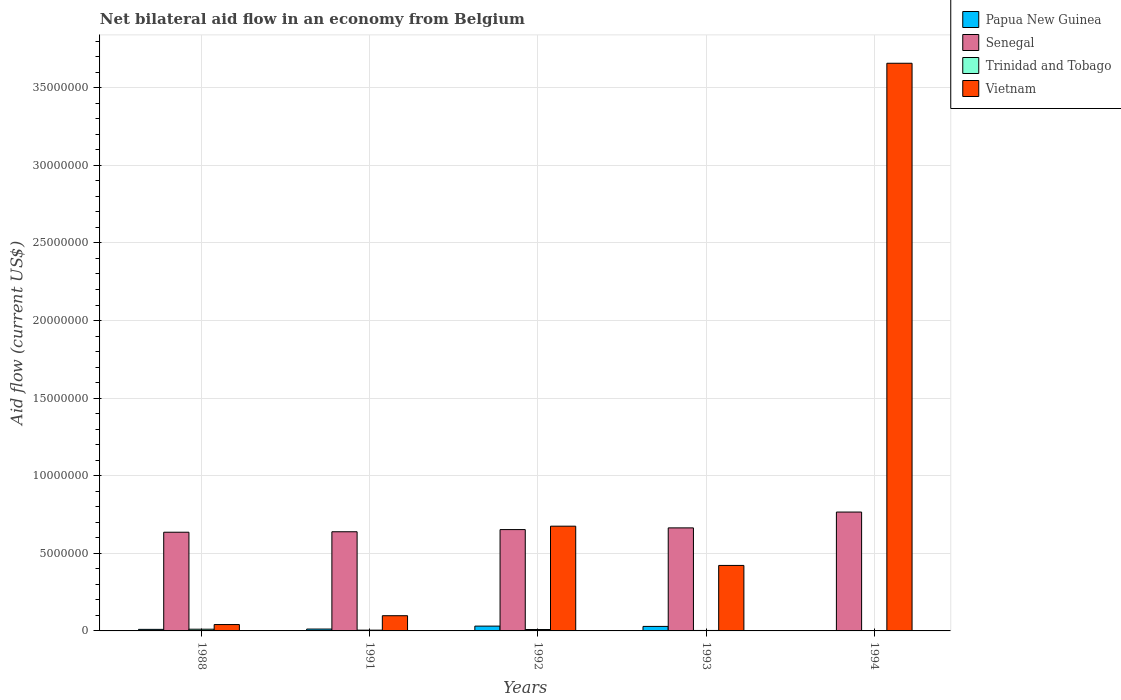Are the number of bars per tick equal to the number of legend labels?
Ensure brevity in your answer.  Yes. Are the number of bars on each tick of the X-axis equal?
Make the answer very short. Yes. How many bars are there on the 4th tick from the right?
Give a very brief answer. 4. In which year was the net bilateral aid flow in Vietnam minimum?
Ensure brevity in your answer.  1988. What is the total net bilateral aid flow in Vietnam in the graph?
Your response must be concise. 4.89e+07. What is the difference between the net bilateral aid flow in Senegal in 1992 and the net bilateral aid flow in Papua New Guinea in 1991?
Provide a short and direct response. 6.41e+06. What is the average net bilateral aid flow in Papua New Guinea per year?
Provide a succinct answer. 1.66e+05. In the year 1993, what is the difference between the net bilateral aid flow in Senegal and net bilateral aid flow in Papua New Guinea?
Offer a very short reply. 6.35e+06. In how many years, is the net bilateral aid flow in Trinidad and Tobago greater than 36000000 US$?
Your answer should be very brief. 0. What is the ratio of the net bilateral aid flow in Trinidad and Tobago in 1988 to that in 1993?
Your response must be concise. 3.67. What is the difference between the highest and the second highest net bilateral aid flow in Trinidad and Tobago?
Ensure brevity in your answer.  2.00e+04. Is the sum of the net bilateral aid flow in Trinidad and Tobago in 1988 and 1992 greater than the maximum net bilateral aid flow in Vietnam across all years?
Your response must be concise. No. Is it the case that in every year, the sum of the net bilateral aid flow in Vietnam and net bilateral aid flow in Senegal is greater than the sum of net bilateral aid flow in Papua New Guinea and net bilateral aid flow in Trinidad and Tobago?
Offer a terse response. Yes. What does the 1st bar from the left in 1993 represents?
Keep it short and to the point. Papua New Guinea. What does the 1st bar from the right in 1988 represents?
Give a very brief answer. Vietnam. How many years are there in the graph?
Make the answer very short. 5. What is the difference between two consecutive major ticks on the Y-axis?
Your answer should be very brief. 5.00e+06. Are the values on the major ticks of Y-axis written in scientific E-notation?
Provide a short and direct response. No. How are the legend labels stacked?
Your answer should be compact. Vertical. What is the title of the graph?
Offer a terse response. Net bilateral aid flow in an economy from Belgium. What is the label or title of the X-axis?
Keep it short and to the point. Years. What is the Aid flow (current US$) of Senegal in 1988?
Your response must be concise. 6.36e+06. What is the Aid flow (current US$) of Vietnam in 1988?
Give a very brief answer. 4.10e+05. What is the Aid flow (current US$) in Papua New Guinea in 1991?
Keep it short and to the point. 1.20e+05. What is the Aid flow (current US$) in Senegal in 1991?
Give a very brief answer. 6.39e+06. What is the Aid flow (current US$) in Trinidad and Tobago in 1991?
Ensure brevity in your answer.  5.00e+04. What is the Aid flow (current US$) in Vietnam in 1991?
Your answer should be compact. 9.80e+05. What is the Aid flow (current US$) of Senegal in 1992?
Provide a short and direct response. 6.53e+06. What is the Aid flow (current US$) in Vietnam in 1992?
Your answer should be compact. 6.75e+06. What is the Aid flow (current US$) in Papua New Guinea in 1993?
Ensure brevity in your answer.  2.90e+05. What is the Aid flow (current US$) of Senegal in 1993?
Ensure brevity in your answer.  6.64e+06. What is the Aid flow (current US$) of Vietnam in 1993?
Keep it short and to the point. 4.22e+06. What is the Aid flow (current US$) of Papua New Guinea in 1994?
Keep it short and to the point. 10000. What is the Aid flow (current US$) in Senegal in 1994?
Your answer should be compact. 7.66e+06. What is the Aid flow (current US$) of Trinidad and Tobago in 1994?
Provide a short and direct response. 10000. What is the Aid flow (current US$) in Vietnam in 1994?
Keep it short and to the point. 3.66e+07. Across all years, what is the maximum Aid flow (current US$) in Senegal?
Ensure brevity in your answer.  7.66e+06. Across all years, what is the maximum Aid flow (current US$) of Vietnam?
Make the answer very short. 3.66e+07. Across all years, what is the minimum Aid flow (current US$) of Senegal?
Your answer should be very brief. 6.36e+06. What is the total Aid flow (current US$) of Papua New Guinea in the graph?
Your response must be concise. 8.30e+05. What is the total Aid flow (current US$) in Senegal in the graph?
Offer a terse response. 3.36e+07. What is the total Aid flow (current US$) of Trinidad and Tobago in the graph?
Your response must be concise. 2.90e+05. What is the total Aid flow (current US$) in Vietnam in the graph?
Provide a short and direct response. 4.89e+07. What is the difference between the Aid flow (current US$) in Trinidad and Tobago in 1988 and that in 1991?
Provide a short and direct response. 6.00e+04. What is the difference between the Aid flow (current US$) of Vietnam in 1988 and that in 1991?
Provide a short and direct response. -5.70e+05. What is the difference between the Aid flow (current US$) of Papua New Guinea in 1988 and that in 1992?
Ensure brevity in your answer.  -2.10e+05. What is the difference between the Aid flow (current US$) of Senegal in 1988 and that in 1992?
Provide a short and direct response. -1.70e+05. What is the difference between the Aid flow (current US$) of Vietnam in 1988 and that in 1992?
Keep it short and to the point. -6.34e+06. What is the difference between the Aid flow (current US$) of Senegal in 1988 and that in 1993?
Offer a terse response. -2.80e+05. What is the difference between the Aid flow (current US$) of Vietnam in 1988 and that in 1993?
Provide a short and direct response. -3.81e+06. What is the difference between the Aid flow (current US$) in Papua New Guinea in 1988 and that in 1994?
Offer a very short reply. 9.00e+04. What is the difference between the Aid flow (current US$) in Senegal in 1988 and that in 1994?
Make the answer very short. -1.30e+06. What is the difference between the Aid flow (current US$) of Trinidad and Tobago in 1988 and that in 1994?
Offer a very short reply. 1.00e+05. What is the difference between the Aid flow (current US$) of Vietnam in 1988 and that in 1994?
Give a very brief answer. -3.62e+07. What is the difference between the Aid flow (current US$) in Senegal in 1991 and that in 1992?
Give a very brief answer. -1.40e+05. What is the difference between the Aid flow (current US$) of Vietnam in 1991 and that in 1992?
Offer a very short reply. -5.77e+06. What is the difference between the Aid flow (current US$) in Senegal in 1991 and that in 1993?
Keep it short and to the point. -2.50e+05. What is the difference between the Aid flow (current US$) of Trinidad and Tobago in 1991 and that in 1993?
Keep it short and to the point. 2.00e+04. What is the difference between the Aid flow (current US$) of Vietnam in 1991 and that in 1993?
Give a very brief answer. -3.24e+06. What is the difference between the Aid flow (current US$) in Senegal in 1991 and that in 1994?
Your answer should be very brief. -1.27e+06. What is the difference between the Aid flow (current US$) in Vietnam in 1991 and that in 1994?
Offer a terse response. -3.56e+07. What is the difference between the Aid flow (current US$) in Papua New Guinea in 1992 and that in 1993?
Your answer should be very brief. 2.00e+04. What is the difference between the Aid flow (current US$) in Trinidad and Tobago in 1992 and that in 1993?
Provide a short and direct response. 6.00e+04. What is the difference between the Aid flow (current US$) in Vietnam in 1992 and that in 1993?
Offer a very short reply. 2.53e+06. What is the difference between the Aid flow (current US$) of Senegal in 1992 and that in 1994?
Provide a short and direct response. -1.13e+06. What is the difference between the Aid flow (current US$) of Trinidad and Tobago in 1992 and that in 1994?
Your response must be concise. 8.00e+04. What is the difference between the Aid flow (current US$) of Vietnam in 1992 and that in 1994?
Provide a succinct answer. -2.98e+07. What is the difference between the Aid flow (current US$) in Senegal in 1993 and that in 1994?
Ensure brevity in your answer.  -1.02e+06. What is the difference between the Aid flow (current US$) of Trinidad and Tobago in 1993 and that in 1994?
Your response must be concise. 2.00e+04. What is the difference between the Aid flow (current US$) of Vietnam in 1993 and that in 1994?
Your answer should be compact. -3.24e+07. What is the difference between the Aid flow (current US$) of Papua New Guinea in 1988 and the Aid flow (current US$) of Senegal in 1991?
Offer a very short reply. -6.29e+06. What is the difference between the Aid flow (current US$) in Papua New Guinea in 1988 and the Aid flow (current US$) in Vietnam in 1991?
Ensure brevity in your answer.  -8.80e+05. What is the difference between the Aid flow (current US$) in Senegal in 1988 and the Aid flow (current US$) in Trinidad and Tobago in 1991?
Provide a short and direct response. 6.31e+06. What is the difference between the Aid flow (current US$) in Senegal in 1988 and the Aid flow (current US$) in Vietnam in 1991?
Keep it short and to the point. 5.38e+06. What is the difference between the Aid flow (current US$) in Trinidad and Tobago in 1988 and the Aid flow (current US$) in Vietnam in 1991?
Keep it short and to the point. -8.70e+05. What is the difference between the Aid flow (current US$) of Papua New Guinea in 1988 and the Aid flow (current US$) of Senegal in 1992?
Your answer should be compact. -6.43e+06. What is the difference between the Aid flow (current US$) of Papua New Guinea in 1988 and the Aid flow (current US$) of Vietnam in 1992?
Your response must be concise. -6.65e+06. What is the difference between the Aid flow (current US$) in Senegal in 1988 and the Aid flow (current US$) in Trinidad and Tobago in 1992?
Your answer should be compact. 6.27e+06. What is the difference between the Aid flow (current US$) of Senegal in 1988 and the Aid flow (current US$) of Vietnam in 1992?
Your answer should be compact. -3.90e+05. What is the difference between the Aid flow (current US$) of Trinidad and Tobago in 1988 and the Aid flow (current US$) of Vietnam in 1992?
Your response must be concise. -6.64e+06. What is the difference between the Aid flow (current US$) in Papua New Guinea in 1988 and the Aid flow (current US$) in Senegal in 1993?
Your response must be concise. -6.54e+06. What is the difference between the Aid flow (current US$) of Papua New Guinea in 1988 and the Aid flow (current US$) of Vietnam in 1993?
Offer a terse response. -4.12e+06. What is the difference between the Aid flow (current US$) of Senegal in 1988 and the Aid flow (current US$) of Trinidad and Tobago in 1993?
Your answer should be compact. 6.33e+06. What is the difference between the Aid flow (current US$) in Senegal in 1988 and the Aid flow (current US$) in Vietnam in 1993?
Offer a terse response. 2.14e+06. What is the difference between the Aid flow (current US$) of Trinidad and Tobago in 1988 and the Aid flow (current US$) of Vietnam in 1993?
Make the answer very short. -4.11e+06. What is the difference between the Aid flow (current US$) of Papua New Guinea in 1988 and the Aid flow (current US$) of Senegal in 1994?
Ensure brevity in your answer.  -7.56e+06. What is the difference between the Aid flow (current US$) in Papua New Guinea in 1988 and the Aid flow (current US$) in Trinidad and Tobago in 1994?
Provide a succinct answer. 9.00e+04. What is the difference between the Aid flow (current US$) of Papua New Guinea in 1988 and the Aid flow (current US$) of Vietnam in 1994?
Make the answer very short. -3.65e+07. What is the difference between the Aid flow (current US$) in Senegal in 1988 and the Aid flow (current US$) in Trinidad and Tobago in 1994?
Make the answer very short. 6.35e+06. What is the difference between the Aid flow (current US$) of Senegal in 1988 and the Aid flow (current US$) of Vietnam in 1994?
Provide a short and direct response. -3.02e+07. What is the difference between the Aid flow (current US$) of Trinidad and Tobago in 1988 and the Aid flow (current US$) of Vietnam in 1994?
Your answer should be compact. -3.65e+07. What is the difference between the Aid flow (current US$) of Papua New Guinea in 1991 and the Aid flow (current US$) of Senegal in 1992?
Ensure brevity in your answer.  -6.41e+06. What is the difference between the Aid flow (current US$) of Papua New Guinea in 1991 and the Aid flow (current US$) of Trinidad and Tobago in 1992?
Your answer should be very brief. 3.00e+04. What is the difference between the Aid flow (current US$) of Papua New Guinea in 1991 and the Aid flow (current US$) of Vietnam in 1992?
Offer a very short reply. -6.63e+06. What is the difference between the Aid flow (current US$) in Senegal in 1991 and the Aid flow (current US$) in Trinidad and Tobago in 1992?
Your response must be concise. 6.30e+06. What is the difference between the Aid flow (current US$) of Senegal in 1991 and the Aid flow (current US$) of Vietnam in 1992?
Your answer should be very brief. -3.60e+05. What is the difference between the Aid flow (current US$) in Trinidad and Tobago in 1991 and the Aid flow (current US$) in Vietnam in 1992?
Provide a succinct answer. -6.70e+06. What is the difference between the Aid flow (current US$) of Papua New Guinea in 1991 and the Aid flow (current US$) of Senegal in 1993?
Offer a terse response. -6.52e+06. What is the difference between the Aid flow (current US$) in Papua New Guinea in 1991 and the Aid flow (current US$) in Vietnam in 1993?
Offer a terse response. -4.10e+06. What is the difference between the Aid flow (current US$) in Senegal in 1991 and the Aid flow (current US$) in Trinidad and Tobago in 1993?
Your response must be concise. 6.36e+06. What is the difference between the Aid flow (current US$) in Senegal in 1991 and the Aid flow (current US$) in Vietnam in 1993?
Keep it short and to the point. 2.17e+06. What is the difference between the Aid flow (current US$) of Trinidad and Tobago in 1991 and the Aid flow (current US$) of Vietnam in 1993?
Offer a very short reply. -4.17e+06. What is the difference between the Aid flow (current US$) of Papua New Guinea in 1991 and the Aid flow (current US$) of Senegal in 1994?
Provide a succinct answer. -7.54e+06. What is the difference between the Aid flow (current US$) in Papua New Guinea in 1991 and the Aid flow (current US$) in Vietnam in 1994?
Your answer should be very brief. -3.65e+07. What is the difference between the Aid flow (current US$) of Senegal in 1991 and the Aid flow (current US$) of Trinidad and Tobago in 1994?
Keep it short and to the point. 6.38e+06. What is the difference between the Aid flow (current US$) of Senegal in 1991 and the Aid flow (current US$) of Vietnam in 1994?
Your answer should be compact. -3.02e+07. What is the difference between the Aid flow (current US$) of Trinidad and Tobago in 1991 and the Aid flow (current US$) of Vietnam in 1994?
Make the answer very short. -3.65e+07. What is the difference between the Aid flow (current US$) in Papua New Guinea in 1992 and the Aid flow (current US$) in Senegal in 1993?
Your answer should be very brief. -6.33e+06. What is the difference between the Aid flow (current US$) in Papua New Guinea in 1992 and the Aid flow (current US$) in Vietnam in 1993?
Your response must be concise. -3.91e+06. What is the difference between the Aid flow (current US$) of Senegal in 1992 and the Aid flow (current US$) of Trinidad and Tobago in 1993?
Offer a terse response. 6.50e+06. What is the difference between the Aid flow (current US$) of Senegal in 1992 and the Aid flow (current US$) of Vietnam in 1993?
Provide a short and direct response. 2.31e+06. What is the difference between the Aid flow (current US$) in Trinidad and Tobago in 1992 and the Aid flow (current US$) in Vietnam in 1993?
Provide a succinct answer. -4.13e+06. What is the difference between the Aid flow (current US$) of Papua New Guinea in 1992 and the Aid flow (current US$) of Senegal in 1994?
Keep it short and to the point. -7.35e+06. What is the difference between the Aid flow (current US$) in Papua New Guinea in 1992 and the Aid flow (current US$) in Trinidad and Tobago in 1994?
Your answer should be very brief. 3.00e+05. What is the difference between the Aid flow (current US$) of Papua New Guinea in 1992 and the Aid flow (current US$) of Vietnam in 1994?
Keep it short and to the point. -3.63e+07. What is the difference between the Aid flow (current US$) in Senegal in 1992 and the Aid flow (current US$) in Trinidad and Tobago in 1994?
Offer a very short reply. 6.52e+06. What is the difference between the Aid flow (current US$) of Senegal in 1992 and the Aid flow (current US$) of Vietnam in 1994?
Offer a terse response. -3.00e+07. What is the difference between the Aid flow (current US$) of Trinidad and Tobago in 1992 and the Aid flow (current US$) of Vietnam in 1994?
Your response must be concise. -3.65e+07. What is the difference between the Aid flow (current US$) in Papua New Guinea in 1993 and the Aid flow (current US$) in Senegal in 1994?
Ensure brevity in your answer.  -7.37e+06. What is the difference between the Aid flow (current US$) in Papua New Guinea in 1993 and the Aid flow (current US$) in Trinidad and Tobago in 1994?
Provide a succinct answer. 2.80e+05. What is the difference between the Aid flow (current US$) in Papua New Guinea in 1993 and the Aid flow (current US$) in Vietnam in 1994?
Provide a succinct answer. -3.63e+07. What is the difference between the Aid flow (current US$) in Senegal in 1993 and the Aid flow (current US$) in Trinidad and Tobago in 1994?
Your answer should be compact. 6.63e+06. What is the difference between the Aid flow (current US$) of Senegal in 1993 and the Aid flow (current US$) of Vietnam in 1994?
Provide a short and direct response. -2.99e+07. What is the difference between the Aid flow (current US$) of Trinidad and Tobago in 1993 and the Aid flow (current US$) of Vietnam in 1994?
Provide a succinct answer. -3.66e+07. What is the average Aid flow (current US$) of Papua New Guinea per year?
Offer a very short reply. 1.66e+05. What is the average Aid flow (current US$) in Senegal per year?
Provide a succinct answer. 6.72e+06. What is the average Aid flow (current US$) in Trinidad and Tobago per year?
Offer a very short reply. 5.80e+04. What is the average Aid flow (current US$) of Vietnam per year?
Offer a terse response. 9.79e+06. In the year 1988, what is the difference between the Aid flow (current US$) of Papua New Guinea and Aid flow (current US$) of Senegal?
Provide a short and direct response. -6.26e+06. In the year 1988, what is the difference between the Aid flow (current US$) in Papua New Guinea and Aid flow (current US$) in Trinidad and Tobago?
Give a very brief answer. -10000. In the year 1988, what is the difference between the Aid flow (current US$) in Papua New Guinea and Aid flow (current US$) in Vietnam?
Your response must be concise. -3.10e+05. In the year 1988, what is the difference between the Aid flow (current US$) in Senegal and Aid flow (current US$) in Trinidad and Tobago?
Ensure brevity in your answer.  6.25e+06. In the year 1988, what is the difference between the Aid flow (current US$) in Senegal and Aid flow (current US$) in Vietnam?
Keep it short and to the point. 5.95e+06. In the year 1988, what is the difference between the Aid flow (current US$) in Trinidad and Tobago and Aid flow (current US$) in Vietnam?
Keep it short and to the point. -3.00e+05. In the year 1991, what is the difference between the Aid flow (current US$) of Papua New Guinea and Aid flow (current US$) of Senegal?
Ensure brevity in your answer.  -6.27e+06. In the year 1991, what is the difference between the Aid flow (current US$) in Papua New Guinea and Aid flow (current US$) in Trinidad and Tobago?
Provide a short and direct response. 7.00e+04. In the year 1991, what is the difference between the Aid flow (current US$) in Papua New Guinea and Aid flow (current US$) in Vietnam?
Keep it short and to the point. -8.60e+05. In the year 1991, what is the difference between the Aid flow (current US$) of Senegal and Aid flow (current US$) of Trinidad and Tobago?
Provide a succinct answer. 6.34e+06. In the year 1991, what is the difference between the Aid flow (current US$) of Senegal and Aid flow (current US$) of Vietnam?
Your answer should be compact. 5.41e+06. In the year 1991, what is the difference between the Aid flow (current US$) of Trinidad and Tobago and Aid flow (current US$) of Vietnam?
Make the answer very short. -9.30e+05. In the year 1992, what is the difference between the Aid flow (current US$) of Papua New Guinea and Aid flow (current US$) of Senegal?
Provide a succinct answer. -6.22e+06. In the year 1992, what is the difference between the Aid flow (current US$) of Papua New Guinea and Aid flow (current US$) of Vietnam?
Ensure brevity in your answer.  -6.44e+06. In the year 1992, what is the difference between the Aid flow (current US$) of Senegal and Aid flow (current US$) of Trinidad and Tobago?
Ensure brevity in your answer.  6.44e+06. In the year 1992, what is the difference between the Aid flow (current US$) of Senegal and Aid flow (current US$) of Vietnam?
Provide a succinct answer. -2.20e+05. In the year 1992, what is the difference between the Aid flow (current US$) of Trinidad and Tobago and Aid flow (current US$) of Vietnam?
Your answer should be very brief. -6.66e+06. In the year 1993, what is the difference between the Aid flow (current US$) of Papua New Guinea and Aid flow (current US$) of Senegal?
Your answer should be very brief. -6.35e+06. In the year 1993, what is the difference between the Aid flow (current US$) in Papua New Guinea and Aid flow (current US$) in Vietnam?
Ensure brevity in your answer.  -3.93e+06. In the year 1993, what is the difference between the Aid flow (current US$) of Senegal and Aid flow (current US$) of Trinidad and Tobago?
Make the answer very short. 6.61e+06. In the year 1993, what is the difference between the Aid flow (current US$) in Senegal and Aid flow (current US$) in Vietnam?
Offer a terse response. 2.42e+06. In the year 1993, what is the difference between the Aid flow (current US$) of Trinidad and Tobago and Aid flow (current US$) of Vietnam?
Keep it short and to the point. -4.19e+06. In the year 1994, what is the difference between the Aid flow (current US$) in Papua New Guinea and Aid flow (current US$) in Senegal?
Give a very brief answer. -7.65e+06. In the year 1994, what is the difference between the Aid flow (current US$) of Papua New Guinea and Aid flow (current US$) of Trinidad and Tobago?
Give a very brief answer. 0. In the year 1994, what is the difference between the Aid flow (current US$) of Papua New Guinea and Aid flow (current US$) of Vietnam?
Give a very brief answer. -3.66e+07. In the year 1994, what is the difference between the Aid flow (current US$) in Senegal and Aid flow (current US$) in Trinidad and Tobago?
Provide a short and direct response. 7.65e+06. In the year 1994, what is the difference between the Aid flow (current US$) in Senegal and Aid flow (current US$) in Vietnam?
Your answer should be compact. -2.89e+07. In the year 1994, what is the difference between the Aid flow (current US$) in Trinidad and Tobago and Aid flow (current US$) in Vietnam?
Your response must be concise. -3.66e+07. What is the ratio of the Aid flow (current US$) in Senegal in 1988 to that in 1991?
Your answer should be compact. 1. What is the ratio of the Aid flow (current US$) in Trinidad and Tobago in 1988 to that in 1991?
Ensure brevity in your answer.  2.2. What is the ratio of the Aid flow (current US$) in Vietnam in 1988 to that in 1991?
Offer a very short reply. 0.42. What is the ratio of the Aid flow (current US$) of Papua New Guinea in 1988 to that in 1992?
Your answer should be very brief. 0.32. What is the ratio of the Aid flow (current US$) in Trinidad and Tobago in 1988 to that in 1992?
Your answer should be compact. 1.22. What is the ratio of the Aid flow (current US$) of Vietnam in 1988 to that in 1992?
Offer a very short reply. 0.06. What is the ratio of the Aid flow (current US$) of Papua New Guinea in 1988 to that in 1993?
Ensure brevity in your answer.  0.34. What is the ratio of the Aid flow (current US$) of Senegal in 1988 to that in 1993?
Provide a short and direct response. 0.96. What is the ratio of the Aid flow (current US$) in Trinidad and Tobago in 1988 to that in 1993?
Your response must be concise. 3.67. What is the ratio of the Aid flow (current US$) of Vietnam in 1988 to that in 1993?
Provide a succinct answer. 0.1. What is the ratio of the Aid flow (current US$) of Papua New Guinea in 1988 to that in 1994?
Provide a short and direct response. 10. What is the ratio of the Aid flow (current US$) in Senegal in 1988 to that in 1994?
Ensure brevity in your answer.  0.83. What is the ratio of the Aid flow (current US$) in Trinidad and Tobago in 1988 to that in 1994?
Your answer should be very brief. 11. What is the ratio of the Aid flow (current US$) of Vietnam in 1988 to that in 1994?
Offer a terse response. 0.01. What is the ratio of the Aid flow (current US$) in Papua New Guinea in 1991 to that in 1992?
Give a very brief answer. 0.39. What is the ratio of the Aid flow (current US$) of Senegal in 1991 to that in 1992?
Keep it short and to the point. 0.98. What is the ratio of the Aid flow (current US$) of Trinidad and Tobago in 1991 to that in 1992?
Your response must be concise. 0.56. What is the ratio of the Aid flow (current US$) of Vietnam in 1991 to that in 1992?
Provide a short and direct response. 0.15. What is the ratio of the Aid flow (current US$) of Papua New Guinea in 1991 to that in 1993?
Provide a succinct answer. 0.41. What is the ratio of the Aid flow (current US$) in Senegal in 1991 to that in 1993?
Keep it short and to the point. 0.96. What is the ratio of the Aid flow (current US$) in Trinidad and Tobago in 1991 to that in 1993?
Provide a short and direct response. 1.67. What is the ratio of the Aid flow (current US$) in Vietnam in 1991 to that in 1993?
Keep it short and to the point. 0.23. What is the ratio of the Aid flow (current US$) of Senegal in 1991 to that in 1994?
Your answer should be compact. 0.83. What is the ratio of the Aid flow (current US$) in Trinidad and Tobago in 1991 to that in 1994?
Your answer should be compact. 5. What is the ratio of the Aid flow (current US$) of Vietnam in 1991 to that in 1994?
Provide a succinct answer. 0.03. What is the ratio of the Aid flow (current US$) in Papua New Guinea in 1992 to that in 1993?
Offer a very short reply. 1.07. What is the ratio of the Aid flow (current US$) of Senegal in 1992 to that in 1993?
Offer a terse response. 0.98. What is the ratio of the Aid flow (current US$) of Trinidad and Tobago in 1992 to that in 1993?
Your answer should be compact. 3. What is the ratio of the Aid flow (current US$) in Vietnam in 1992 to that in 1993?
Offer a terse response. 1.6. What is the ratio of the Aid flow (current US$) in Papua New Guinea in 1992 to that in 1994?
Provide a short and direct response. 31. What is the ratio of the Aid flow (current US$) in Senegal in 1992 to that in 1994?
Your response must be concise. 0.85. What is the ratio of the Aid flow (current US$) of Vietnam in 1992 to that in 1994?
Give a very brief answer. 0.18. What is the ratio of the Aid flow (current US$) in Senegal in 1993 to that in 1994?
Make the answer very short. 0.87. What is the ratio of the Aid flow (current US$) in Trinidad and Tobago in 1993 to that in 1994?
Offer a terse response. 3. What is the ratio of the Aid flow (current US$) of Vietnam in 1993 to that in 1994?
Offer a terse response. 0.12. What is the difference between the highest and the second highest Aid flow (current US$) of Senegal?
Provide a short and direct response. 1.02e+06. What is the difference between the highest and the second highest Aid flow (current US$) of Trinidad and Tobago?
Keep it short and to the point. 2.00e+04. What is the difference between the highest and the second highest Aid flow (current US$) in Vietnam?
Provide a short and direct response. 2.98e+07. What is the difference between the highest and the lowest Aid flow (current US$) of Papua New Guinea?
Make the answer very short. 3.00e+05. What is the difference between the highest and the lowest Aid flow (current US$) in Senegal?
Your response must be concise. 1.30e+06. What is the difference between the highest and the lowest Aid flow (current US$) in Vietnam?
Your answer should be compact. 3.62e+07. 